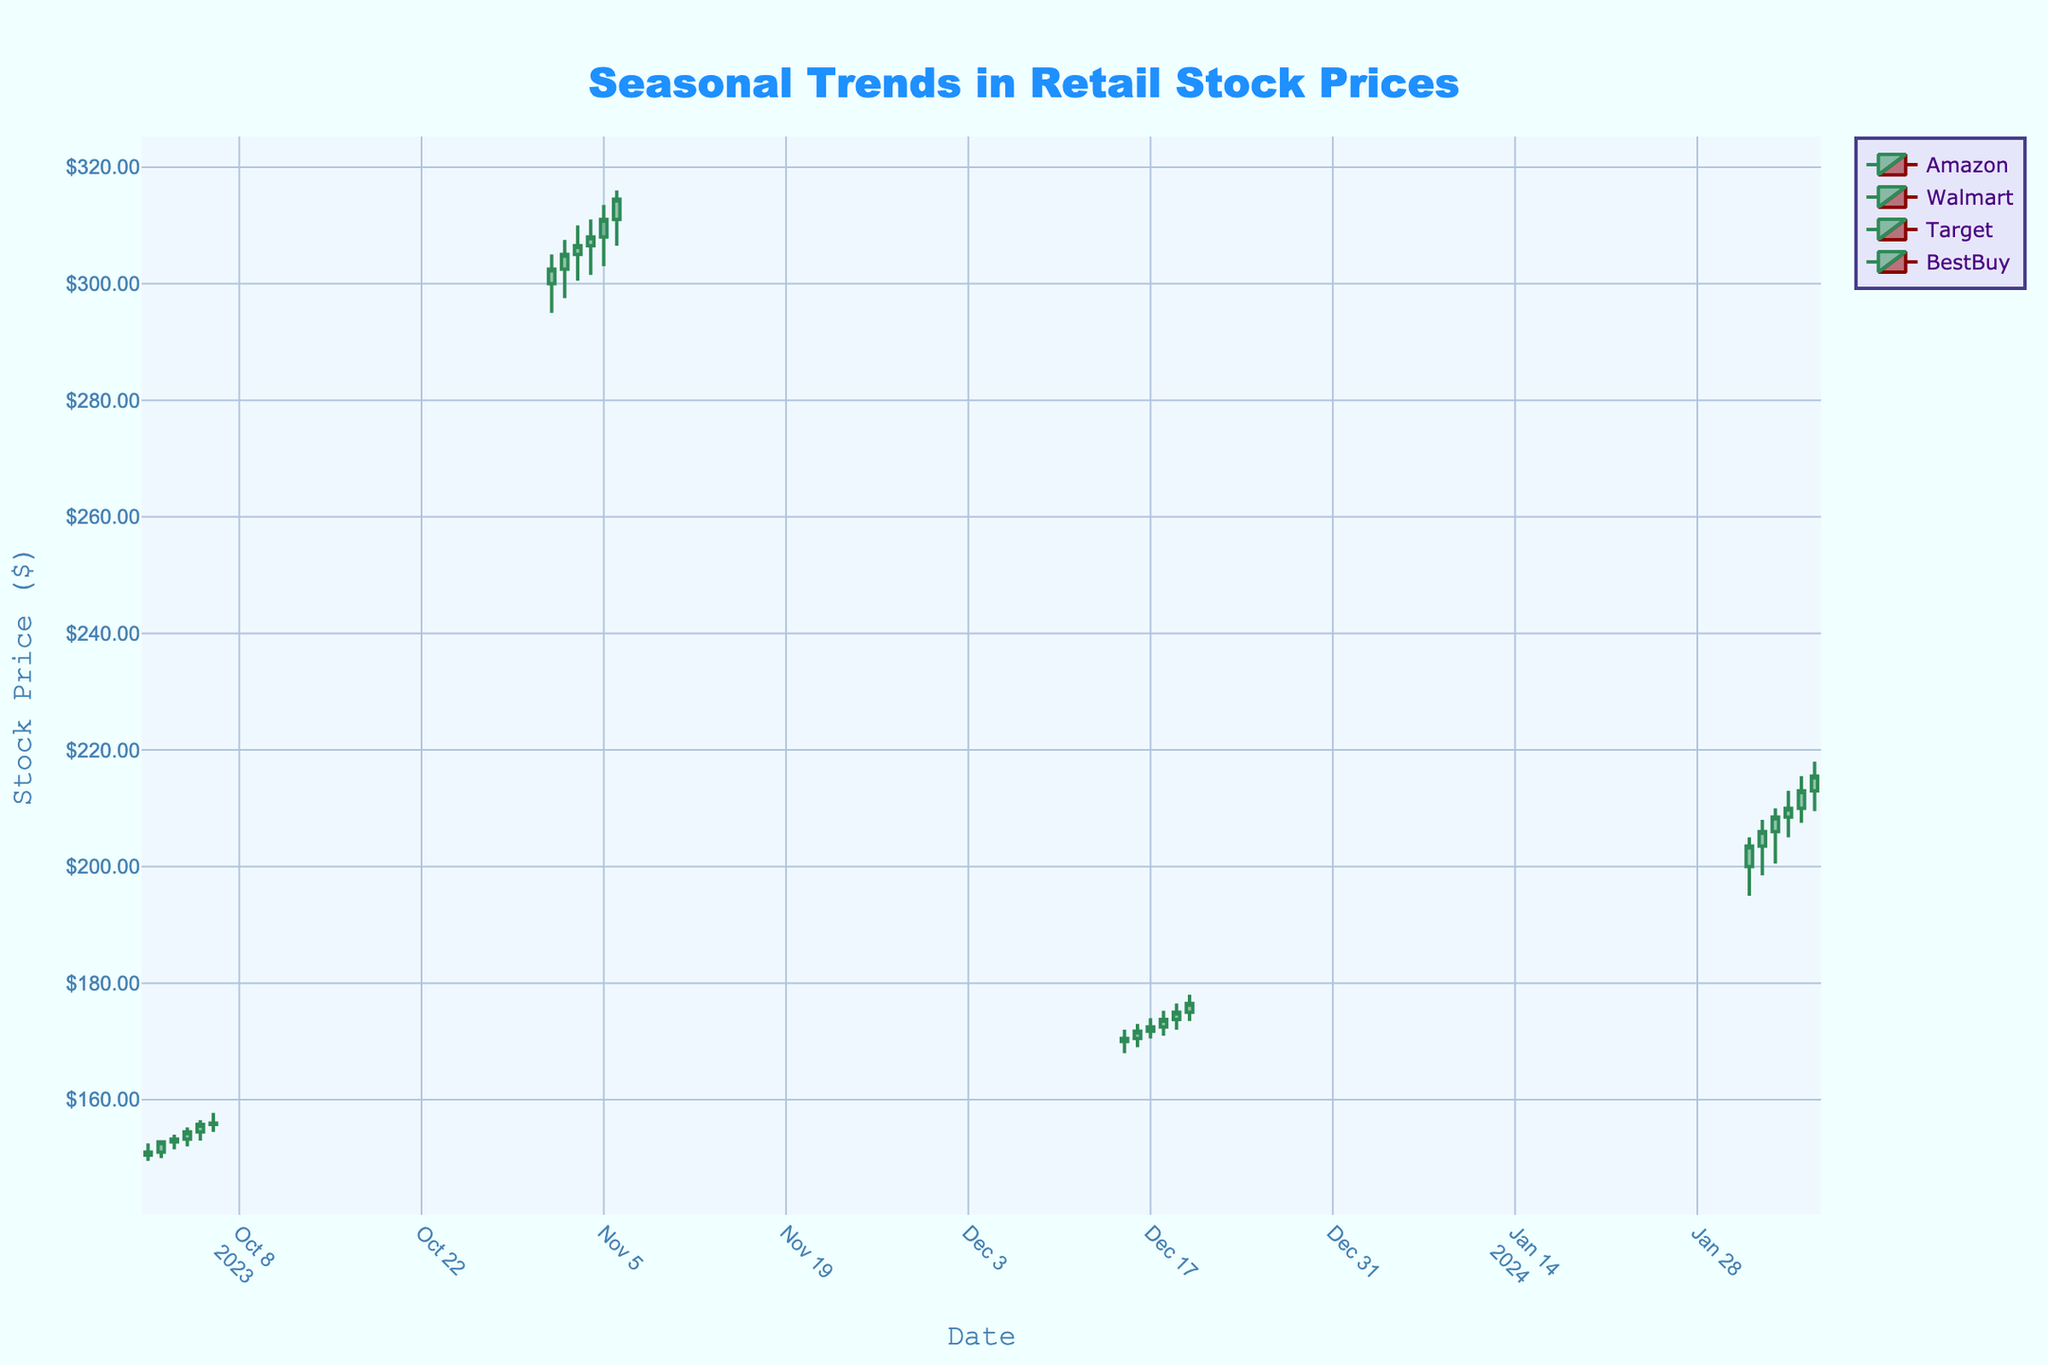What's the title of the figure? The title of the figure is usually displayed at the top center in a larger font and distinct color. The title describes the figure content. Here, it says "Seasonal Trends in Retail Stock Prices".
Answer: Seasonal Trends in Retail Stock Prices What do the colors green and red represent in the candlestick plot? In a candlestick plot, the green color typically represents an increase in stock price (closing price higher than the opening price), while the red color represents a decrease in stock price (closing price lower than the opening price). These colors help to quickly identify stock performance.
Answer: Increase and decrease in stock price On which date did Amazon have the highest closing price in October 2023? To find the highest closing price for Amazon in October 2023, look for the candlestick that extends the highest on the y-axis within the date range. The highest closing price in October for Amazon is on October 6, where the closing price was the tallest among the October dates.
Answer: October 6 Compare the closing price of Walmart on November 6th to its opening price on the same day. Did it increase or decrease? To compare the closing and opening prices for Walmart on November 6th, observe the candlestick for that date. The closing price (314.50) is higher than the opening price (311.00), indicating an increase.
Answer: Increase What was the trend of Target’s stock prices from December 15 to December 20, 2023? Check the sequential candlesticks for Target from December 15 to December 20. Notice how each closing price progressively gets higher. This indicates a positive trend over the specified period where the stock price steadily increased each day.
Answer: Increasing Did BestBuy’s closing price on February 6, 2024, exceed 215.00? Check the candlestick for BestBuy on February 6. Observe the closing price for that date. The closing price is 215.50, which is slightly above 215.00.
Answer: Yes Which stock had the highest trading volume in the provided data range? Compare the volume across all stocks. Look for the volume data corresponding to each date. The highest value noted is 6500000 for BestBuy on February 6, 2024.
Answer: BestBuy Calculate the average closing price of Walmart from November 1 to November 6, 2023. To calculate the average closing price for Walmart over the specified period, sum up the closing prices: (302.50 + 305.00 + 306.50 + 308.00 + 311.00 + 314.50) = 1847.50, then divide by the number of days (6). So, the average closing price is 1847.50 / 6.
Answer: 307.92 Which stock showed the most substantial percentage increase from the first to the last recorded day in its data range? Calculate the percentage increase for each stock:
- Amazon (Oct 1 to Oct 6): ((156.00 - 151.00) / 151.00) * 100 ≈ 3.31%
- Walmart (Nov 1 to Nov 6): ((314.50 - 302.50) / 302.50) * 100 ≈ 3.97%
- Target (Dec 15 to Dec 20): ((176.50 - 170.50) / 170.50) * 100 ≈ 3.52%
- BestBuy (Feb 1 to Feb 6): ((215.50 - 203.50) / 203.50) * 100 ≈ 5.90%
BestBuy has the highest percentage increase.
Answer: BestBuy 